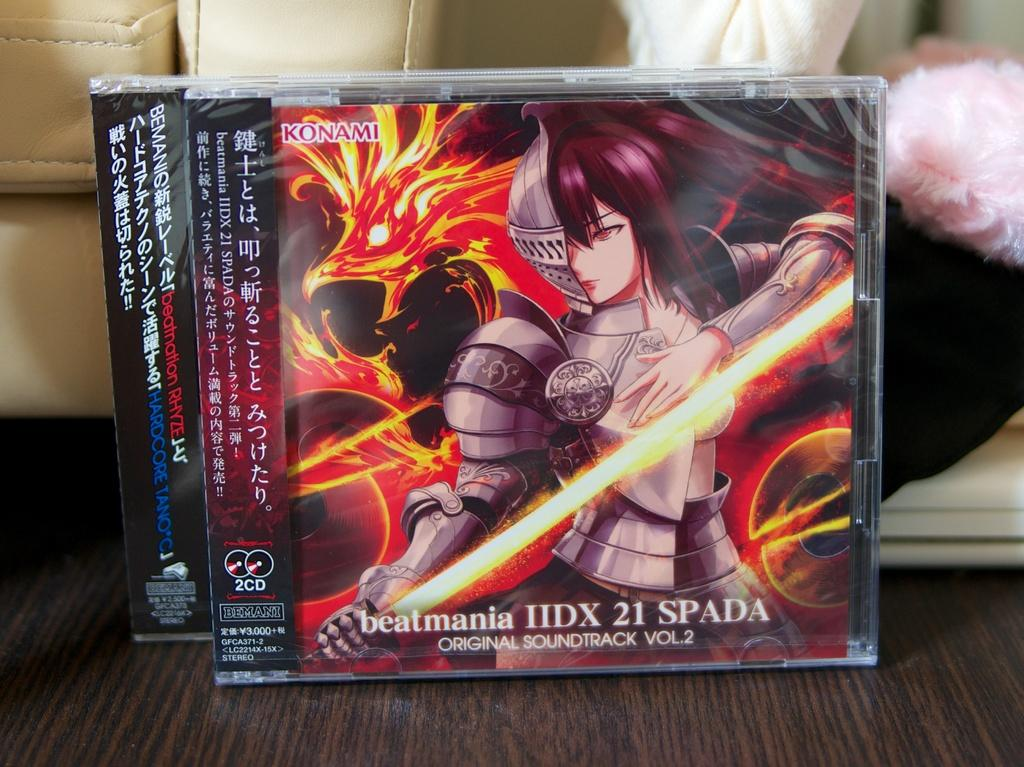<image>
Describe the image concisely. Videogame cover showing a woman with a sword made by Konami. 